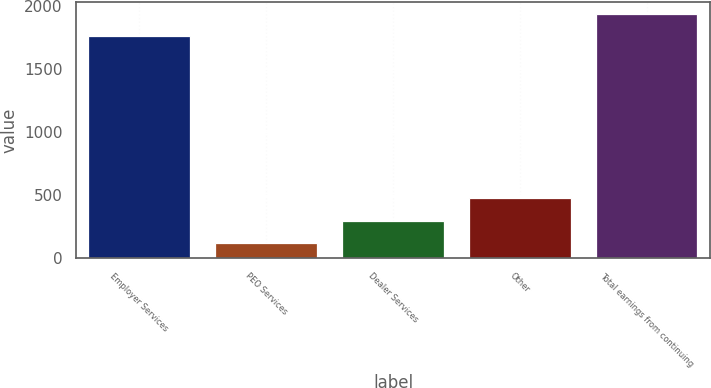<chart> <loc_0><loc_0><loc_500><loc_500><bar_chart><fcel>Employer Services<fcel>PEO Services<fcel>Dealer Services<fcel>Other<fcel>Total earnings from continuing<nl><fcel>1758.7<fcel>117.6<fcel>295.85<fcel>474.1<fcel>1936.95<nl></chart> 